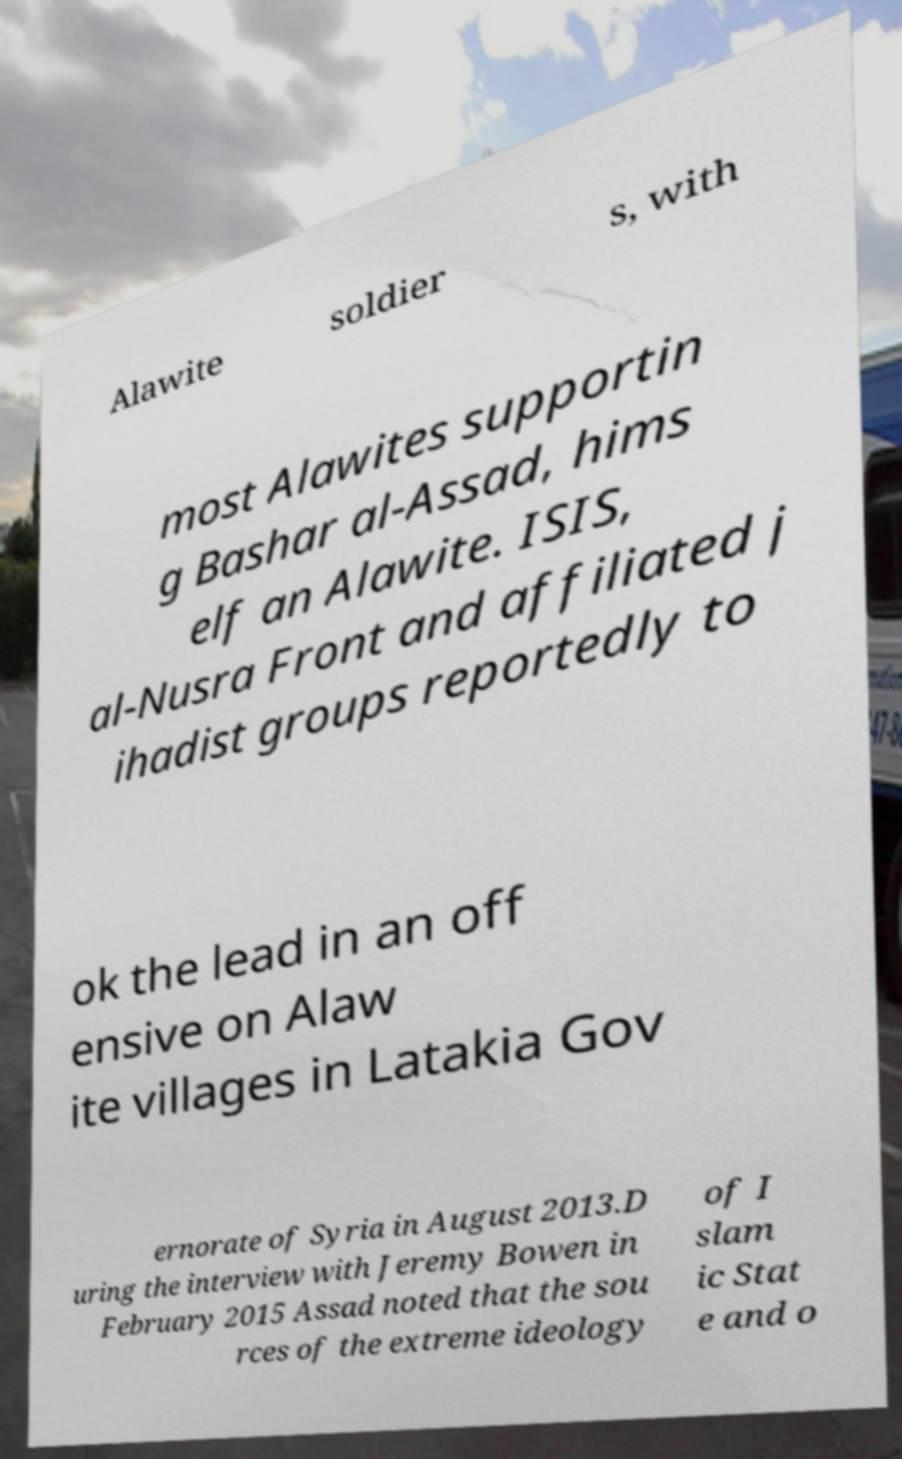What messages or text are displayed in this image? I need them in a readable, typed format. Alawite soldier s, with most Alawites supportin g Bashar al-Assad, hims elf an Alawite. ISIS, al-Nusra Front and affiliated j ihadist groups reportedly to ok the lead in an off ensive on Alaw ite villages in Latakia Gov ernorate of Syria in August 2013.D uring the interview with Jeremy Bowen in February 2015 Assad noted that the sou rces of the extreme ideology of I slam ic Stat e and o 